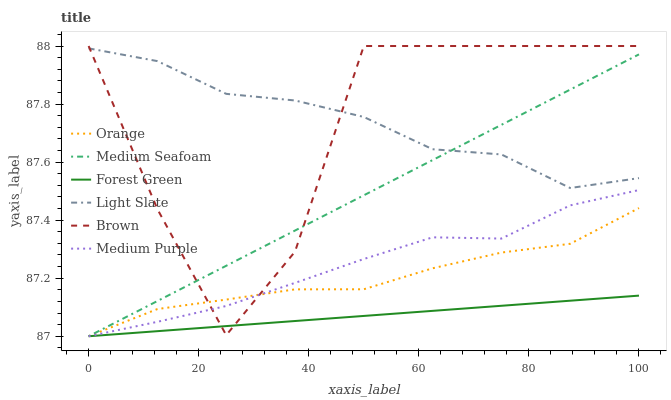Does Forest Green have the minimum area under the curve?
Answer yes or no. Yes. Does Light Slate have the maximum area under the curve?
Answer yes or no. Yes. Does Medium Purple have the minimum area under the curve?
Answer yes or no. No. Does Medium Purple have the maximum area under the curve?
Answer yes or no. No. Is Forest Green the smoothest?
Answer yes or no. Yes. Is Brown the roughest?
Answer yes or no. Yes. Is Light Slate the smoothest?
Answer yes or no. No. Is Light Slate the roughest?
Answer yes or no. No. Does Medium Purple have the lowest value?
Answer yes or no. Yes. Does Light Slate have the lowest value?
Answer yes or no. No. Does Brown have the highest value?
Answer yes or no. Yes. Does Light Slate have the highest value?
Answer yes or no. No. Is Orange less than Light Slate?
Answer yes or no. Yes. Is Light Slate greater than Orange?
Answer yes or no. Yes. Does Medium Purple intersect Medium Seafoam?
Answer yes or no. Yes. Is Medium Purple less than Medium Seafoam?
Answer yes or no. No. Is Medium Purple greater than Medium Seafoam?
Answer yes or no. No. Does Orange intersect Light Slate?
Answer yes or no. No. 